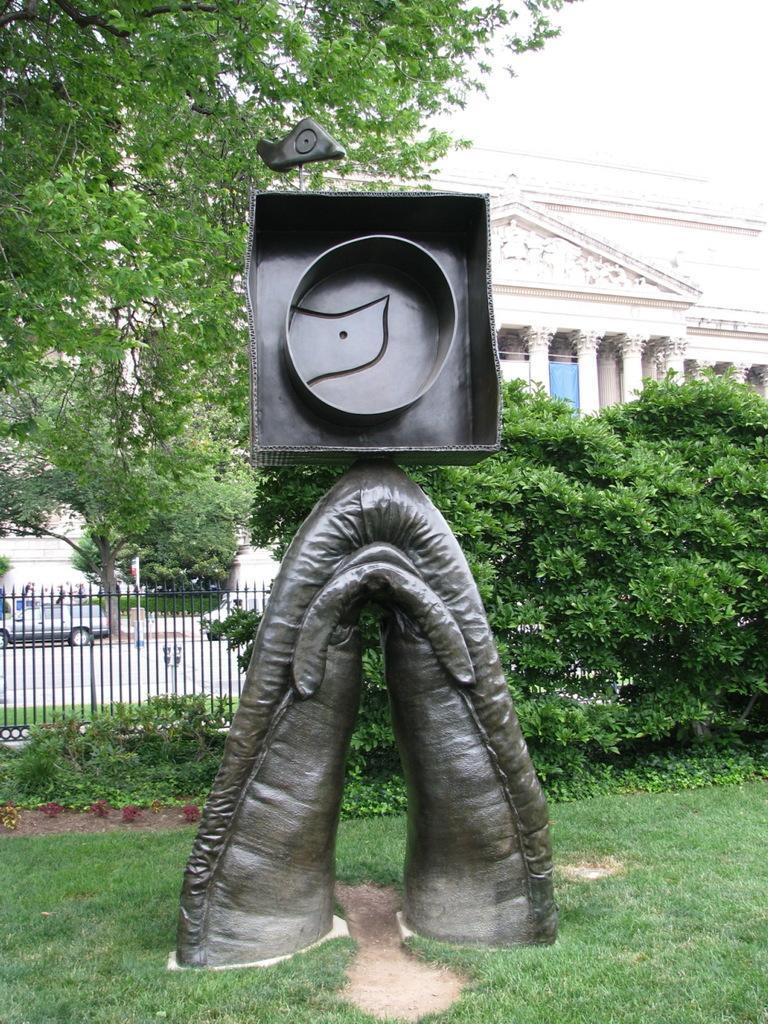Please provide a concise description of this image. In this image in the center there is a design. In the background there are trees, there is a building, and there is a fence and a car on the road. In the front on the ground there is grass. 